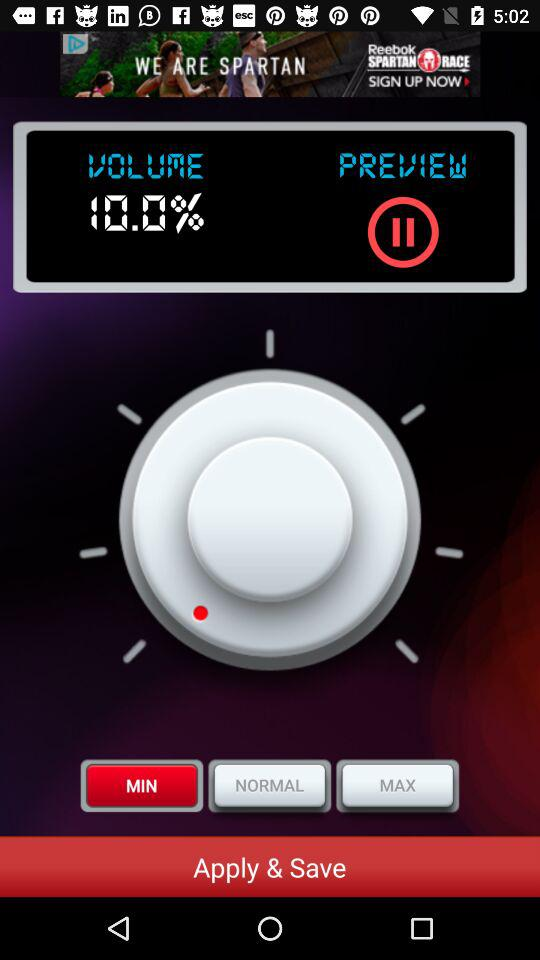Is the volume "MIN" or "MAX"? The volume is "MIN". 